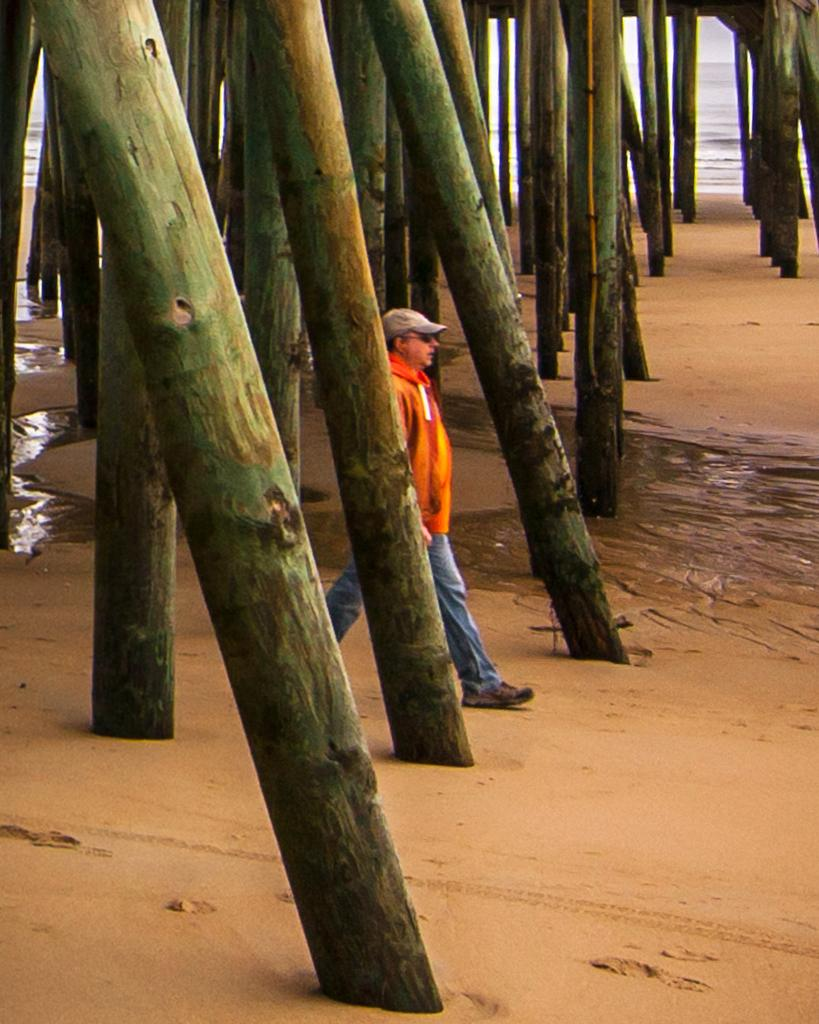Who is present in the image? There is a man in the image. What is the man doing in the image? The man is walking on sand. What objects can be seen in the image besides the man? There are wooden poles in the image. What can be seen in the background of the image? There is a sea visible in the background of the image. What type of fear does the goat have in the image? There is no goat present in the image, so it is not possible to determine any fear it might have. 